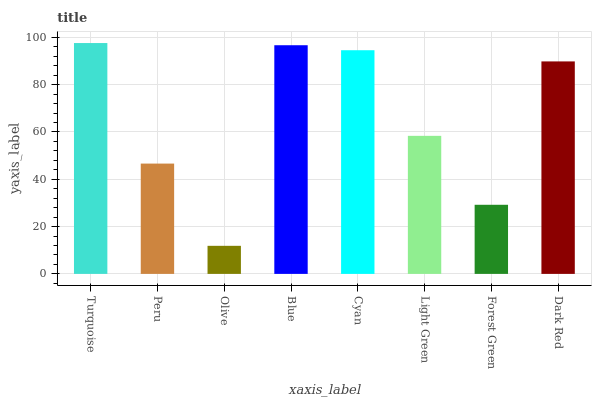Is Olive the minimum?
Answer yes or no. Yes. Is Turquoise the maximum?
Answer yes or no. Yes. Is Peru the minimum?
Answer yes or no. No. Is Peru the maximum?
Answer yes or no. No. Is Turquoise greater than Peru?
Answer yes or no. Yes. Is Peru less than Turquoise?
Answer yes or no. Yes. Is Peru greater than Turquoise?
Answer yes or no. No. Is Turquoise less than Peru?
Answer yes or no. No. Is Dark Red the high median?
Answer yes or no. Yes. Is Light Green the low median?
Answer yes or no. Yes. Is Forest Green the high median?
Answer yes or no. No. Is Peru the low median?
Answer yes or no. No. 